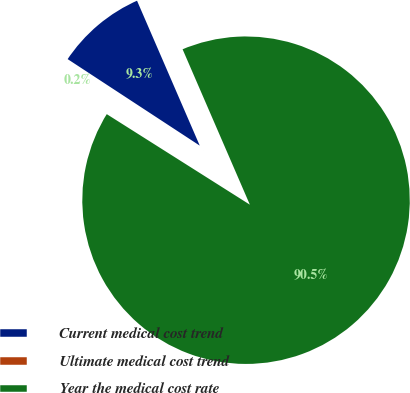Convert chart. <chart><loc_0><loc_0><loc_500><loc_500><pie_chart><fcel>Current medical cost trend<fcel>Ultimate medical cost trend<fcel>Year the medical cost rate<nl><fcel>9.27%<fcel>0.25%<fcel>90.48%<nl></chart> 